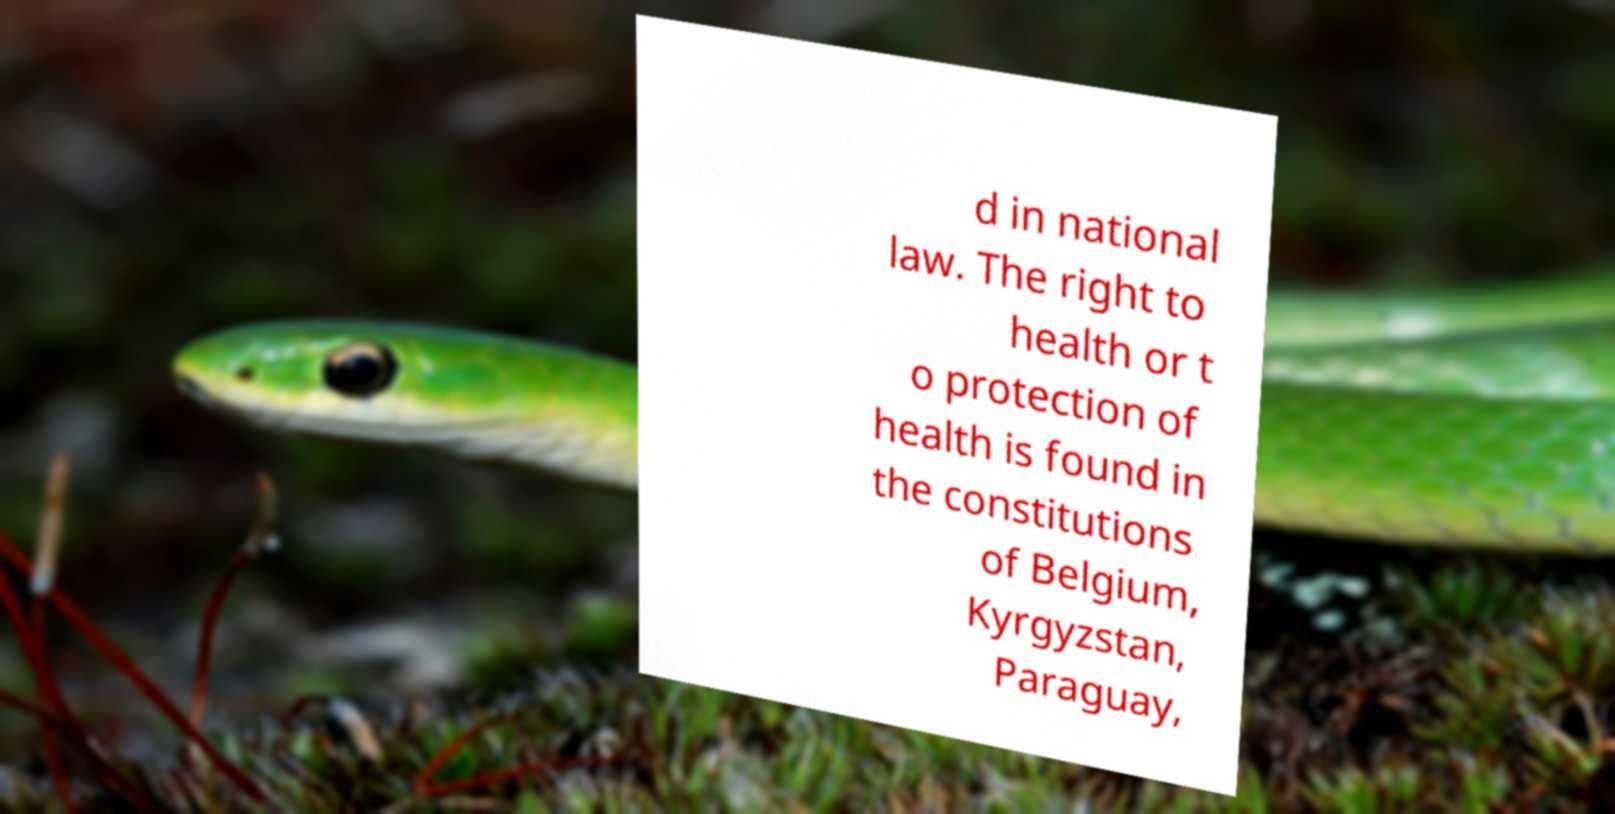Please identify and transcribe the text found in this image. d in national law. The right to health or t o protection of health is found in the constitutions of Belgium, Kyrgyzstan, Paraguay, 